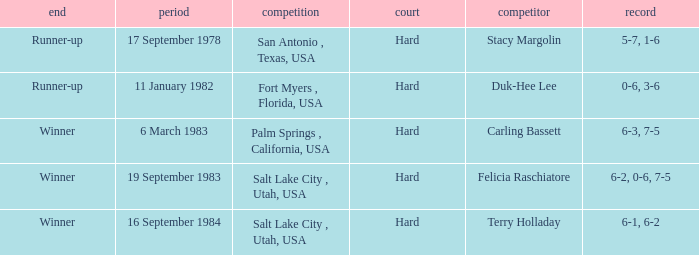What was the outcome of the match against Stacy Margolin? Runner-up. Could you help me parse every detail presented in this table? {'header': ['end', 'period', 'competition', 'court', 'competitor', 'record'], 'rows': [['Runner-up', '17 September 1978', 'San Antonio , Texas, USA', 'Hard', 'Stacy Margolin', '5-7, 1-6'], ['Runner-up', '11 January 1982', 'Fort Myers , Florida, USA', 'Hard', 'Duk-Hee Lee', '0-6, 3-6'], ['Winner', '6 March 1983', 'Palm Springs , California, USA', 'Hard', 'Carling Bassett', '6-3, 7-5'], ['Winner', '19 September 1983', 'Salt Lake City , Utah, USA', 'Hard', 'Felicia Raschiatore', '6-2, 0-6, 7-5'], ['Winner', '16 September 1984', 'Salt Lake City , Utah, USA', 'Hard', 'Terry Holladay', '6-1, 6-2']]} 